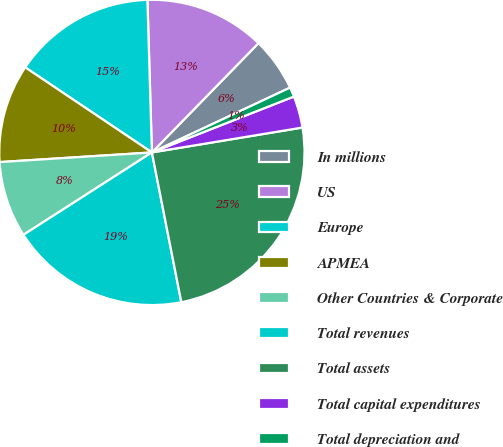Convert chart. <chart><loc_0><loc_0><loc_500><loc_500><pie_chart><fcel>In millions<fcel>US<fcel>Europe<fcel>APMEA<fcel>Other Countries & Corporate<fcel>Total revenues<fcel>Total assets<fcel>Total capital expenditures<fcel>Total depreciation and<nl><fcel>5.72%<fcel>12.77%<fcel>15.12%<fcel>10.42%<fcel>8.07%<fcel>19.01%<fcel>24.52%<fcel>3.36%<fcel>1.01%<nl></chart> 